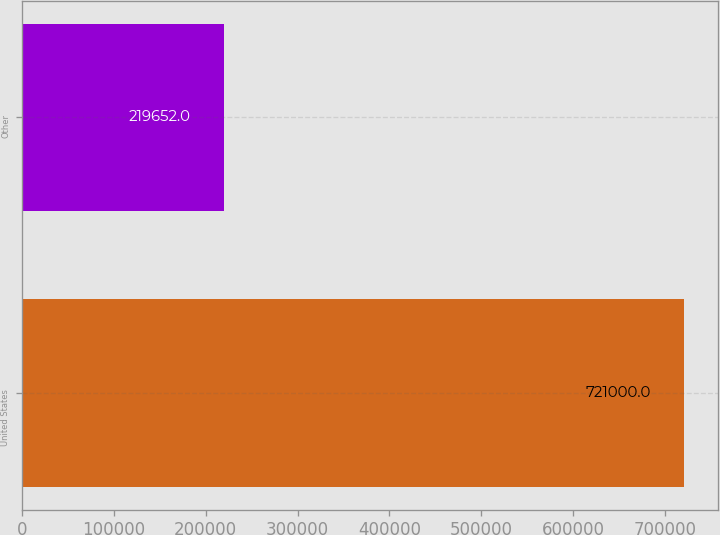Convert chart to OTSL. <chart><loc_0><loc_0><loc_500><loc_500><bar_chart><fcel>United States<fcel>Other<nl><fcel>721000<fcel>219652<nl></chart> 